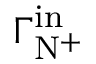<formula> <loc_0><loc_0><loc_500><loc_500>\Gamma _ { N ^ { + } } ^ { i n }</formula> 